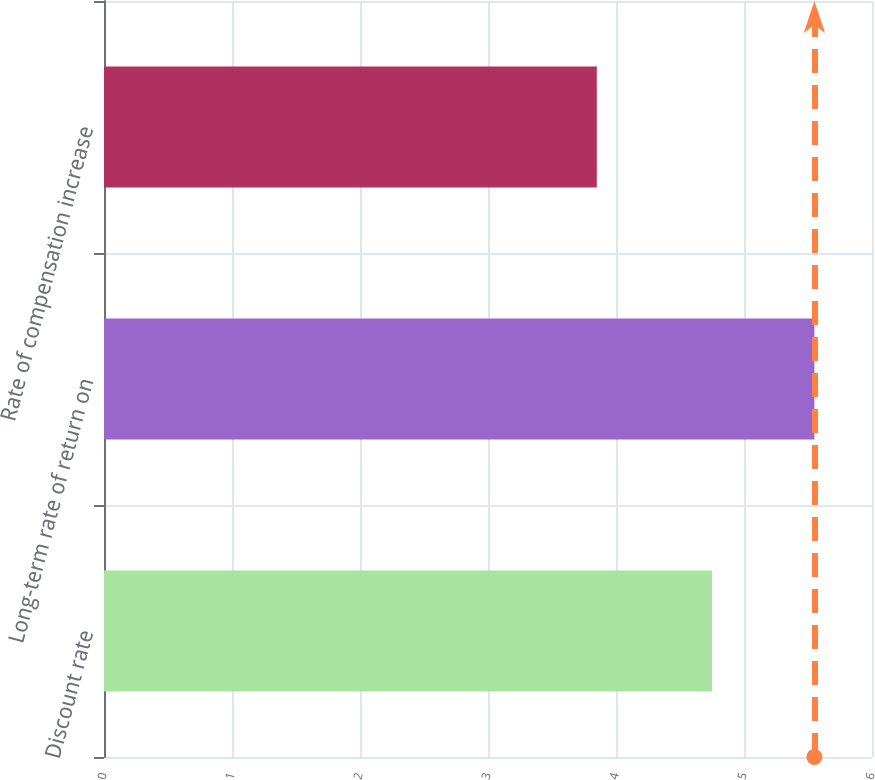Convert chart. <chart><loc_0><loc_0><loc_500><loc_500><bar_chart><fcel>Discount rate<fcel>Long-term rate of return on<fcel>Rate of compensation increase<nl><fcel>4.75<fcel>5.55<fcel>3.85<nl></chart> 